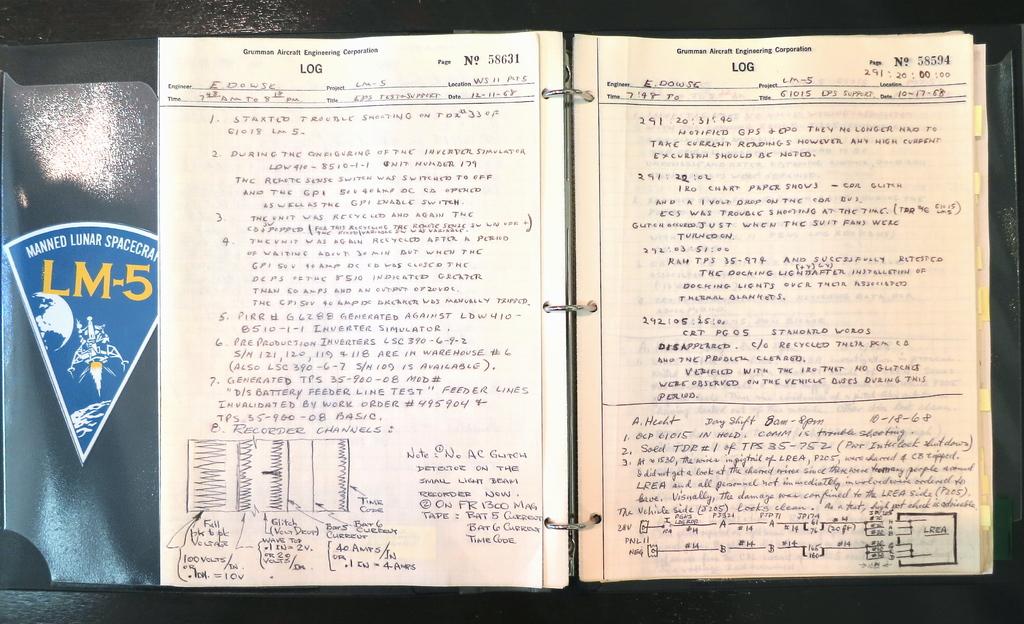What is the blue emblem?
Your answer should be compact. Lm-5. 